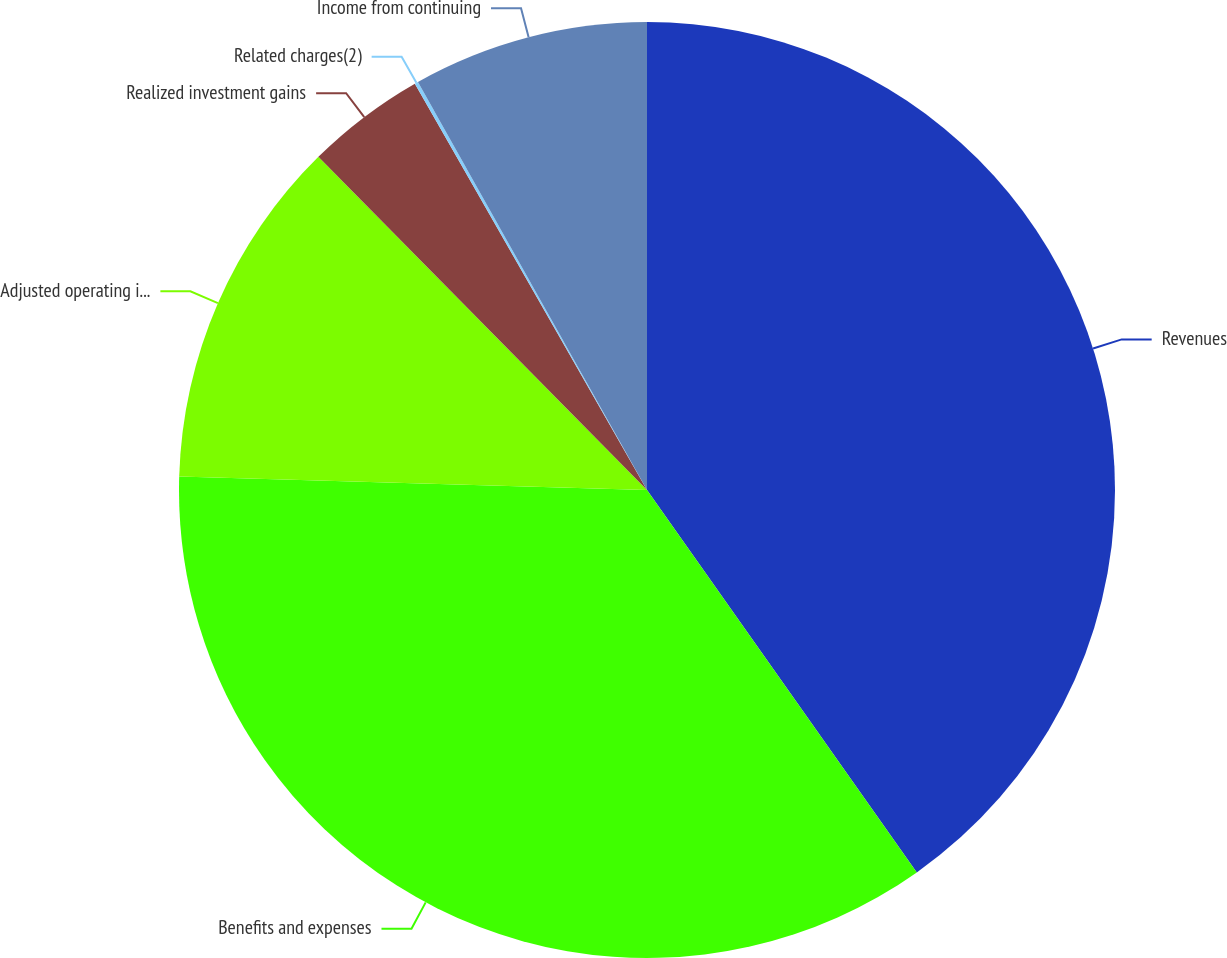Convert chart. <chart><loc_0><loc_0><loc_500><loc_500><pie_chart><fcel>Revenues<fcel>Benefits and expenses<fcel>Adjusted operating income<fcel>Realized investment gains<fcel>Related charges(2)<fcel>Income from continuing<nl><fcel>40.22%<fcel>35.24%<fcel>12.15%<fcel>4.13%<fcel>0.12%<fcel>8.14%<nl></chart> 